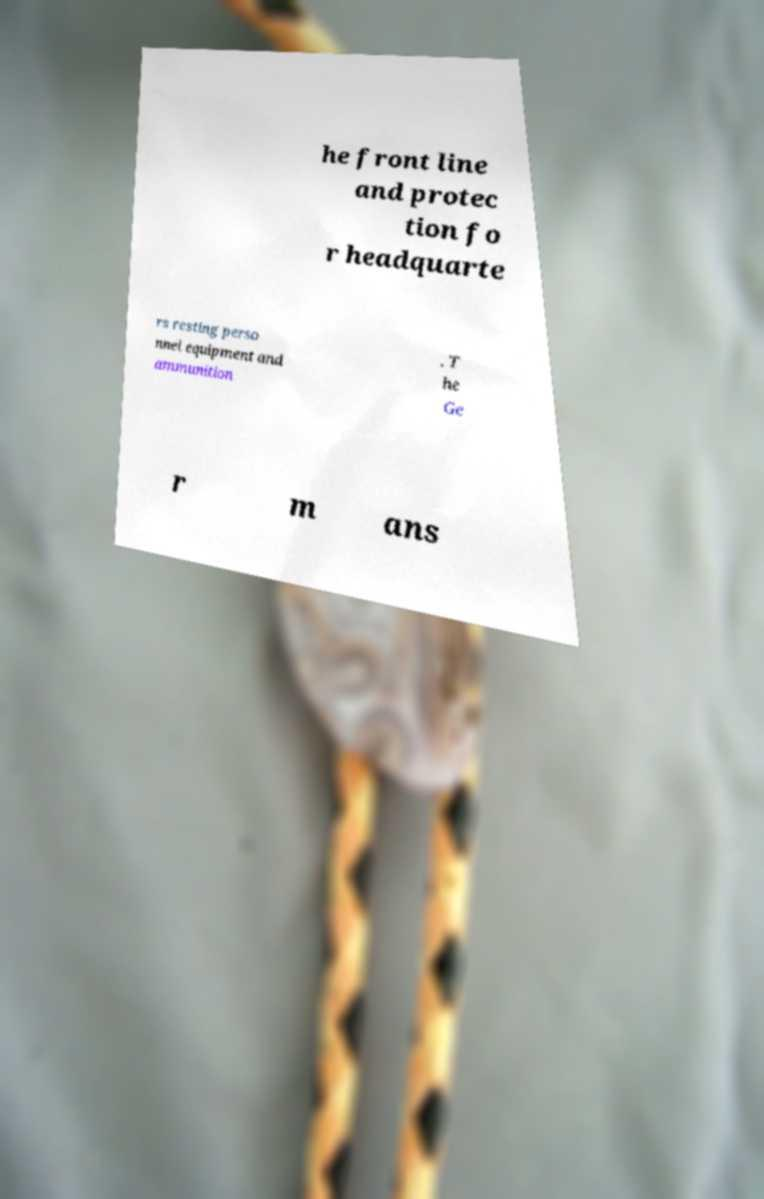What messages or text are displayed in this image? I need them in a readable, typed format. he front line and protec tion fo r headquarte rs resting perso nnel equipment and ammunition . T he Ge r m ans 